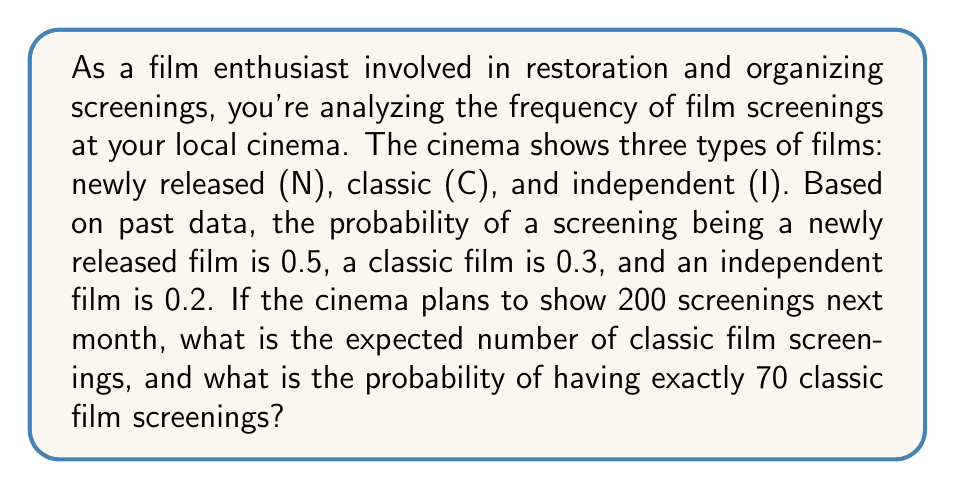Can you answer this question? To solve this problem, we'll use concepts from probability and statistics, specifically expected value and the binomial probability distribution.

1. Expected number of classic film screenings:
   The expected value is calculated by multiplying the probability of an event by the number of trials.
   
   $$ E(X) = np $$
   
   Where:
   $n$ = number of screenings (200)
   $p$ = probability of a classic film screening (0.3)

   $$ E(X) = 200 \times 0.3 = 60 $$

2. Probability of exactly 70 classic film screenings:
   This follows a binomial distribution. We'll use the binomial probability formula:

   $$ P(X = k) = \binom{n}{k} p^k (1-p)^{n-k} $$

   Where:
   $n$ = number of screenings (200)
   $k$ = number of successful outcomes (70)
   $p$ = probability of a classic film screening (0.3)

   $$ P(X = 70) = \binom{200}{70} (0.3)^{70} (0.7)^{130} $$

   Using a calculator or computer (due to the large numbers involved):

   $$ P(X = 70) \approx 0.0399 $$
Answer: The expected number of classic film screenings is 60. The probability of having exactly 70 classic film screenings is approximately 0.0399 or 3.99%. 